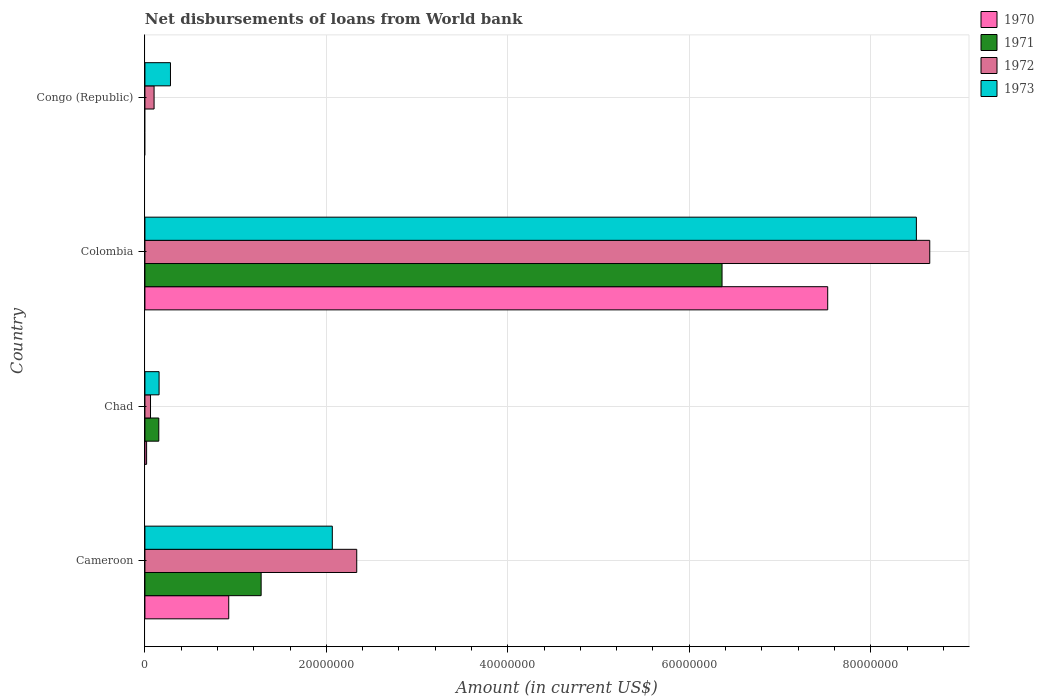How many groups of bars are there?
Offer a terse response. 4. Are the number of bars on each tick of the Y-axis equal?
Provide a succinct answer. No. How many bars are there on the 4th tick from the top?
Your answer should be very brief. 4. How many bars are there on the 2nd tick from the bottom?
Keep it short and to the point. 4. What is the label of the 1st group of bars from the top?
Provide a succinct answer. Congo (Republic). What is the amount of loan disbursed from World Bank in 1971 in Chad?
Provide a short and direct response. 1.53e+06. Across all countries, what is the maximum amount of loan disbursed from World Bank in 1970?
Keep it short and to the point. 7.53e+07. Across all countries, what is the minimum amount of loan disbursed from World Bank in 1970?
Make the answer very short. 0. What is the total amount of loan disbursed from World Bank in 1971 in the graph?
Provide a short and direct response. 7.80e+07. What is the difference between the amount of loan disbursed from World Bank in 1971 in Cameroon and that in Colombia?
Offer a very short reply. -5.08e+07. What is the difference between the amount of loan disbursed from World Bank in 1970 in Colombia and the amount of loan disbursed from World Bank in 1973 in Congo (Republic)?
Your response must be concise. 7.24e+07. What is the average amount of loan disbursed from World Bank in 1972 per country?
Offer a very short reply. 2.79e+07. What is the difference between the amount of loan disbursed from World Bank in 1971 and amount of loan disbursed from World Bank in 1970 in Chad?
Give a very brief answer. 1.34e+06. What is the ratio of the amount of loan disbursed from World Bank in 1970 in Cameroon to that in Chad?
Provide a short and direct response. 49.67. Is the difference between the amount of loan disbursed from World Bank in 1971 in Chad and Colombia greater than the difference between the amount of loan disbursed from World Bank in 1970 in Chad and Colombia?
Offer a terse response. Yes. What is the difference between the highest and the second highest amount of loan disbursed from World Bank in 1970?
Give a very brief answer. 6.60e+07. What is the difference between the highest and the lowest amount of loan disbursed from World Bank in 1971?
Keep it short and to the point. 6.36e+07. In how many countries, is the amount of loan disbursed from World Bank in 1970 greater than the average amount of loan disbursed from World Bank in 1970 taken over all countries?
Offer a terse response. 1. Is the sum of the amount of loan disbursed from World Bank in 1973 in Cameroon and Colombia greater than the maximum amount of loan disbursed from World Bank in 1971 across all countries?
Your answer should be compact. Yes. How many bars are there?
Provide a short and direct response. 14. What is the difference between two consecutive major ticks on the X-axis?
Ensure brevity in your answer.  2.00e+07. Does the graph contain grids?
Offer a very short reply. Yes. What is the title of the graph?
Provide a short and direct response. Net disbursements of loans from World bank. What is the label or title of the X-axis?
Your response must be concise. Amount (in current US$). What is the Amount (in current US$) of 1970 in Cameroon?
Keep it short and to the point. 9.24e+06. What is the Amount (in current US$) in 1971 in Cameroon?
Provide a short and direct response. 1.28e+07. What is the Amount (in current US$) in 1972 in Cameroon?
Your response must be concise. 2.33e+07. What is the Amount (in current US$) in 1973 in Cameroon?
Make the answer very short. 2.07e+07. What is the Amount (in current US$) of 1970 in Chad?
Give a very brief answer. 1.86e+05. What is the Amount (in current US$) of 1971 in Chad?
Offer a very short reply. 1.53e+06. What is the Amount (in current US$) of 1972 in Chad?
Your answer should be compact. 6.17e+05. What is the Amount (in current US$) in 1973 in Chad?
Make the answer very short. 1.56e+06. What is the Amount (in current US$) of 1970 in Colombia?
Provide a succinct answer. 7.53e+07. What is the Amount (in current US$) of 1971 in Colombia?
Your answer should be compact. 6.36e+07. What is the Amount (in current US$) of 1972 in Colombia?
Offer a very short reply. 8.65e+07. What is the Amount (in current US$) in 1973 in Colombia?
Your answer should be very brief. 8.50e+07. What is the Amount (in current US$) in 1971 in Congo (Republic)?
Offer a very short reply. 0. What is the Amount (in current US$) of 1972 in Congo (Republic)?
Offer a terse response. 1.01e+06. What is the Amount (in current US$) of 1973 in Congo (Republic)?
Your answer should be very brief. 2.82e+06. Across all countries, what is the maximum Amount (in current US$) in 1970?
Provide a succinct answer. 7.53e+07. Across all countries, what is the maximum Amount (in current US$) in 1971?
Your answer should be compact. 6.36e+07. Across all countries, what is the maximum Amount (in current US$) in 1972?
Your answer should be very brief. 8.65e+07. Across all countries, what is the maximum Amount (in current US$) of 1973?
Offer a very short reply. 8.50e+07. Across all countries, what is the minimum Amount (in current US$) in 1970?
Make the answer very short. 0. Across all countries, what is the minimum Amount (in current US$) in 1972?
Your response must be concise. 6.17e+05. Across all countries, what is the minimum Amount (in current US$) of 1973?
Offer a very short reply. 1.56e+06. What is the total Amount (in current US$) of 1970 in the graph?
Give a very brief answer. 8.47e+07. What is the total Amount (in current US$) of 1971 in the graph?
Your answer should be very brief. 7.80e+07. What is the total Amount (in current US$) of 1972 in the graph?
Provide a short and direct response. 1.11e+08. What is the total Amount (in current US$) in 1973 in the graph?
Give a very brief answer. 1.10e+08. What is the difference between the Amount (in current US$) of 1970 in Cameroon and that in Chad?
Offer a terse response. 9.05e+06. What is the difference between the Amount (in current US$) of 1971 in Cameroon and that in Chad?
Offer a very short reply. 1.13e+07. What is the difference between the Amount (in current US$) of 1972 in Cameroon and that in Chad?
Your answer should be very brief. 2.27e+07. What is the difference between the Amount (in current US$) in 1973 in Cameroon and that in Chad?
Provide a succinct answer. 1.91e+07. What is the difference between the Amount (in current US$) in 1970 in Cameroon and that in Colombia?
Provide a short and direct response. -6.60e+07. What is the difference between the Amount (in current US$) in 1971 in Cameroon and that in Colombia?
Your answer should be compact. -5.08e+07. What is the difference between the Amount (in current US$) of 1972 in Cameroon and that in Colombia?
Keep it short and to the point. -6.32e+07. What is the difference between the Amount (in current US$) of 1973 in Cameroon and that in Colombia?
Offer a very short reply. -6.44e+07. What is the difference between the Amount (in current US$) of 1972 in Cameroon and that in Congo (Republic)?
Provide a short and direct response. 2.23e+07. What is the difference between the Amount (in current US$) of 1973 in Cameroon and that in Congo (Republic)?
Ensure brevity in your answer.  1.78e+07. What is the difference between the Amount (in current US$) of 1970 in Chad and that in Colombia?
Provide a short and direct response. -7.51e+07. What is the difference between the Amount (in current US$) in 1971 in Chad and that in Colombia?
Your answer should be compact. -6.21e+07. What is the difference between the Amount (in current US$) of 1972 in Chad and that in Colombia?
Give a very brief answer. -8.59e+07. What is the difference between the Amount (in current US$) of 1973 in Chad and that in Colombia?
Give a very brief answer. -8.35e+07. What is the difference between the Amount (in current US$) of 1972 in Chad and that in Congo (Republic)?
Offer a terse response. -3.92e+05. What is the difference between the Amount (in current US$) in 1973 in Chad and that in Congo (Republic)?
Your response must be concise. -1.26e+06. What is the difference between the Amount (in current US$) in 1972 in Colombia and that in Congo (Republic)?
Your response must be concise. 8.55e+07. What is the difference between the Amount (in current US$) of 1973 in Colombia and that in Congo (Republic)?
Make the answer very short. 8.22e+07. What is the difference between the Amount (in current US$) of 1970 in Cameroon and the Amount (in current US$) of 1971 in Chad?
Provide a succinct answer. 7.71e+06. What is the difference between the Amount (in current US$) of 1970 in Cameroon and the Amount (in current US$) of 1972 in Chad?
Ensure brevity in your answer.  8.62e+06. What is the difference between the Amount (in current US$) in 1970 in Cameroon and the Amount (in current US$) in 1973 in Chad?
Provide a succinct answer. 7.68e+06. What is the difference between the Amount (in current US$) of 1971 in Cameroon and the Amount (in current US$) of 1972 in Chad?
Keep it short and to the point. 1.22e+07. What is the difference between the Amount (in current US$) in 1971 in Cameroon and the Amount (in current US$) in 1973 in Chad?
Make the answer very short. 1.13e+07. What is the difference between the Amount (in current US$) in 1972 in Cameroon and the Amount (in current US$) in 1973 in Chad?
Your answer should be very brief. 2.18e+07. What is the difference between the Amount (in current US$) in 1970 in Cameroon and the Amount (in current US$) in 1971 in Colombia?
Keep it short and to the point. -5.44e+07. What is the difference between the Amount (in current US$) in 1970 in Cameroon and the Amount (in current US$) in 1972 in Colombia?
Offer a very short reply. -7.73e+07. What is the difference between the Amount (in current US$) of 1970 in Cameroon and the Amount (in current US$) of 1973 in Colombia?
Keep it short and to the point. -7.58e+07. What is the difference between the Amount (in current US$) in 1971 in Cameroon and the Amount (in current US$) in 1972 in Colombia?
Make the answer very short. -7.37e+07. What is the difference between the Amount (in current US$) of 1971 in Cameroon and the Amount (in current US$) of 1973 in Colombia?
Offer a very short reply. -7.22e+07. What is the difference between the Amount (in current US$) in 1972 in Cameroon and the Amount (in current US$) in 1973 in Colombia?
Your answer should be compact. -6.17e+07. What is the difference between the Amount (in current US$) of 1970 in Cameroon and the Amount (in current US$) of 1972 in Congo (Republic)?
Offer a very short reply. 8.23e+06. What is the difference between the Amount (in current US$) of 1970 in Cameroon and the Amount (in current US$) of 1973 in Congo (Republic)?
Your answer should be compact. 6.42e+06. What is the difference between the Amount (in current US$) in 1971 in Cameroon and the Amount (in current US$) in 1972 in Congo (Republic)?
Offer a terse response. 1.18e+07. What is the difference between the Amount (in current US$) of 1971 in Cameroon and the Amount (in current US$) of 1973 in Congo (Republic)?
Provide a succinct answer. 1.00e+07. What is the difference between the Amount (in current US$) of 1972 in Cameroon and the Amount (in current US$) of 1973 in Congo (Republic)?
Your answer should be very brief. 2.05e+07. What is the difference between the Amount (in current US$) in 1970 in Chad and the Amount (in current US$) in 1971 in Colombia?
Offer a terse response. -6.34e+07. What is the difference between the Amount (in current US$) in 1970 in Chad and the Amount (in current US$) in 1972 in Colombia?
Your answer should be compact. -8.63e+07. What is the difference between the Amount (in current US$) of 1970 in Chad and the Amount (in current US$) of 1973 in Colombia?
Ensure brevity in your answer.  -8.48e+07. What is the difference between the Amount (in current US$) of 1971 in Chad and the Amount (in current US$) of 1972 in Colombia?
Keep it short and to the point. -8.50e+07. What is the difference between the Amount (in current US$) of 1971 in Chad and the Amount (in current US$) of 1973 in Colombia?
Ensure brevity in your answer.  -8.35e+07. What is the difference between the Amount (in current US$) in 1972 in Chad and the Amount (in current US$) in 1973 in Colombia?
Keep it short and to the point. -8.44e+07. What is the difference between the Amount (in current US$) in 1970 in Chad and the Amount (in current US$) in 1972 in Congo (Republic)?
Provide a succinct answer. -8.23e+05. What is the difference between the Amount (in current US$) of 1970 in Chad and the Amount (in current US$) of 1973 in Congo (Republic)?
Offer a terse response. -2.63e+06. What is the difference between the Amount (in current US$) in 1971 in Chad and the Amount (in current US$) in 1972 in Congo (Republic)?
Your answer should be very brief. 5.21e+05. What is the difference between the Amount (in current US$) in 1971 in Chad and the Amount (in current US$) in 1973 in Congo (Republic)?
Provide a short and direct response. -1.29e+06. What is the difference between the Amount (in current US$) in 1972 in Chad and the Amount (in current US$) in 1973 in Congo (Republic)?
Offer a very short reply. -2.20e+06. What is the difference between the Amount (in current US$) in 1970 in Colombia and the Amount (in current US$) in 1972 in Congo (Republic)?
Your response must be concise. 7.42e+07. What is the difference between the Amount (in current US$) of 1970 in Colombia and the Amount (in current US$) of 1973 in Congo (Republic)?
Your answer should be compact. 7.24e+07. What is the difference between the Amount (in current US$) of 1971 in Colombia and the Amount (in current US$) of 1972 in Congo (Republic)?
Make the answer very short. 6.26e+07. What is the difference between the Amount (in current US$) of 1971 in Colombia and the Amount (in current US$) of 1973 in Congo (Republic)?
Keep it short and to the point. 6.08e+07. What is the difference between the Amount (in current US$) of 1972 in Colombia and the Amount (in current US$) of 1973 in Congo (Republic)?
Your response must be concise. 8.37e+07. What is the average Amount (in current US$) of 1970 per country?
Offer a terse response. 2.12e+07. What is the average Amount (in current US$) of 1971 per country?
Ensure brevity in your answer.  1.95e+07. What is the average Amount (in current US$) in 1972 per country?
Keep it short and to the point. 2.79e+07. What is the average Amount (in current US$) of 1973 per country?
Offer a terse response. 2.75e+07. What is the difference between the Amount (in current US$) of 1970 and Amount (in current US$) of 1971 in Cameroon?
Offer a terse response. -3.57e+06. What is the difference between the Amount (in current US$) of 1970 and Amount (in current US$) of 1972 in Cameroon?
Keep it short and to the point. -1.41e+07. What is the difference between the Amount (in current US$) of 1970 and Amount (in current US$) of 1973 in Cameroon?
Ensure brevity in your answer.  -1.14e+07. What is the difference between the Amount (in current US$) in 1971 and Amount (in current US$) in 1972 in Cameroon?
Your answer should be very brief. -1.05e+07. What is the difference between the Amount (in current US$) in 1971 and Amount (in current US$) in 1973 in Cameroon?
Your answer should be compact. -7.84e+06. What is the difference between the Amount (in current US$) of 1972 and Amount (in current US$) of 1973 in Cameroon?
Offer a very short reply. 2.69e+06. What is the difference between the Amount (in current US$) of 1970 and Amount (in current US$) of 1971 in Chad?
Make the answer very short. -1.34e+06. What is the difference between the Amount (in current US$) of 1970 and Amount (in current US$) of 1972 in Chad?
Offer a terse response. -4.31e+05. What is the difference between the Amount (in current US$) of 1970 and Amount (in current US$) of 1973 in Chad?
Keep it short and to the point. -1.37e+06. What is the difference between the Amount (in current US$) in 1971 and Amount (in current US$) in 1972 in Chad?
Keep it short and to the point. 9.13e+05. What is the difference between the Amount (in current US$) of 1972 and Amount (in current US$) of 1973 in Chad?
Keep it short and to the point. -9.43e+05. What is the difference between the Amount (in current US$) in 1970 and Amount (in current US$) in 1971 in Colombia?
Make the answer very short. 1.16e+07. What is the difference between the Amount (in current US$) of 1970 and Amount (in current US$) of 1972 in Colombia?
Offer a terse response. -1.12e+07. What is the difference between the Amount (in current US$) in 1970 and Amount (in current US$) in 1973 in Colombia?
Your answer should be very brief. -9.77e+06. What is the difference between the Amount (in current US$) of 1971 and Amount (in current US$) of 1972 in Colombia?
Ensure brevity in your answer.  -2.29e+07. What is the difference between the Amount (in current US$) in 1971 and Amount (in current US$) in 1973 in Colombia?
Your answer should be compact. -2.14e+07. What is the difference between the Amount (in current US$) in 1972 and Amount (in current US$) in 1973 in Colombia?
Keep it short and to the point. 1.47e+06. What is the difference between the Amount (in current US$) in 1972 and Amount (in current US$) in 1973 in Congo (Republic)?
Your response must be concise. -1.81e+06. What is the ratio of the Amount (in current US$) of 1970 in Cameroon to that in Chad?
Keep it short and to the point. 49.67. What is the ratio of the Amount (in current US$) of 1971 in Cameroon to that in Chad?
Make the answer very short. 8.37. What is the ratio of the Amount (in current US$) in 1972 in Cameroon to that in Chad?
Offer a very short reply. 37.84. What is the ratio of the Amount (in current US$) in 1973 in Cameroon to that in Chad?
Your answer should be compact. 13.24. What is the ratio of the Amount (in current US$) of 1970 in Cameroon to that in Colombia?
Offer a terse response. 0.12. What is the ratio of the Amount (in current US$) of 1971 in Cameroon to that in Colombia?
Ensure brevity in your answer.  0.2. What is the ratio of the Amount (in current US$) in 1972 in Cameroon to that in Colombia?
Your answer should be compact. 0.27. What is the ratio of the Amount (in current US$) of 1973 in Cameroon to that in Colombia?
Make the answer very short. 0.24. What is the ratio of the Amount (in current US$) of 1972 in Cameroon to that in Congo (Republic)?
Keep it short and to the point. 23.14. What is the ratio of the Amount (in current US$) in 1973 in Cameroon to that in Congo (Republic)?
Your answer should be compact. 7.33. What is the ratio of the Amount (in current US$) of 1970 in Chad to that in Colombia?
Give a very brief answer. 0. What is the ratio of the Amount (in current US$) of 1971 in Chad to that in Colombia?
Ensure brevity in your answer.  0.02. What is the ratio of the Amount (in current US$) in 1972 in Chad to that in Colombia?
Your response must be concise. 0.01. What is the ratio of the Amount (in current US$) in 1973 in Chad to that in Colombia?
Provide a succinct answer. 0.02. What is the ratio of the Amount (in current US$) of 1972 in Chad to that in Congo (Republic)?
Your response must be concise. 0.61. What is the ratio of the Amount (in current US$) in 1973 in Chad to that in Congo (Republic)?
Offer a terse response. 0.55. What is the ratio of the Amount (in current US$) in 1972 in Colombia to that in Congo (Republic)?
Give a very brief answer. 85.74. What is the ratio of the Amount (in current US$) in 1973 in Colombia to that in Congo (Republic)?
Your answer should be compact. 30.2. What is the difference between the highest and the second highest Amount (in current US$) of 1970?
Give a very brief answer. 6.60e+07. What is the difference between the highest and the second highest Amount (in current US$) in 1971?
Your response must be concise. 5.08e+07. What is the difference between the highest and the second highest Amount (in current US$) in 1972?
Your answer should be very brief. 6.32e+07. What is the difference between the highest and the second highest Amount (in current US$) of 1973?
Offer a very short reply. 6.44e+07. What is the difference between the highest and the lowest Amount (in current US$) of 1970?
Offer a very short reply. 7.53e+07. What is the difference between the highest and the lowest Amount (in current US$) in 1971?
Make the answer very short. 6.36e+07. What is the difference between the highest and the lowest Amount (in current US$) of 1972?
Offer a very short reply. 8.59e+07. What is the difference between the highest and the lowest Amount (in current US$) of 1973?
Your response must be concise. 8.35e+07. 